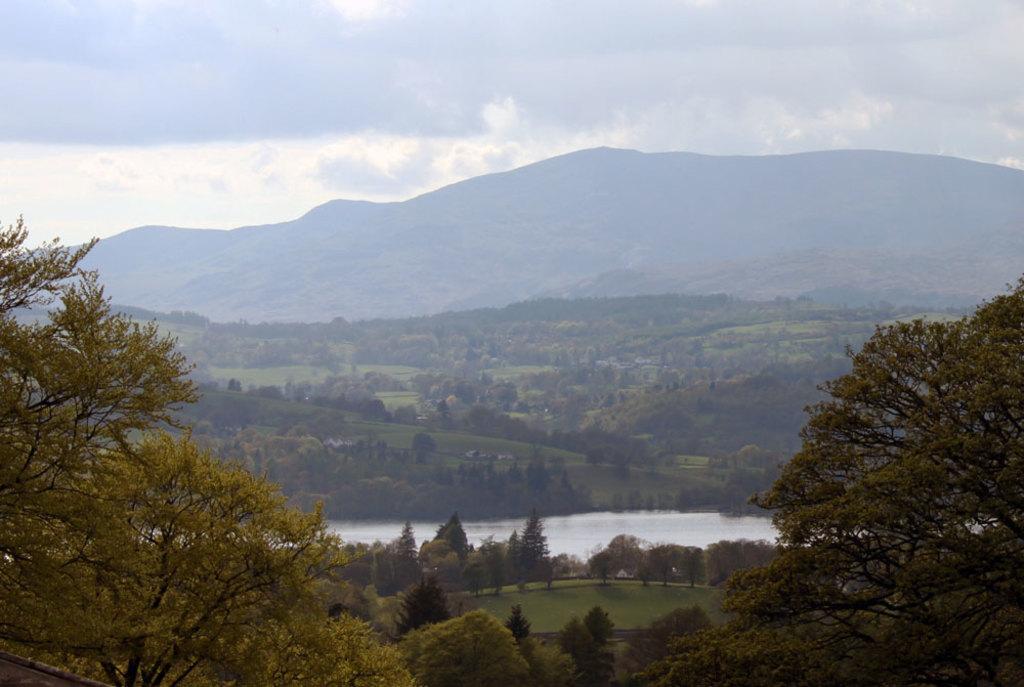Can you describe this image briefly? In the center of the image there is a canal. At the bottom there are trees. In the background there are hills and sky. 